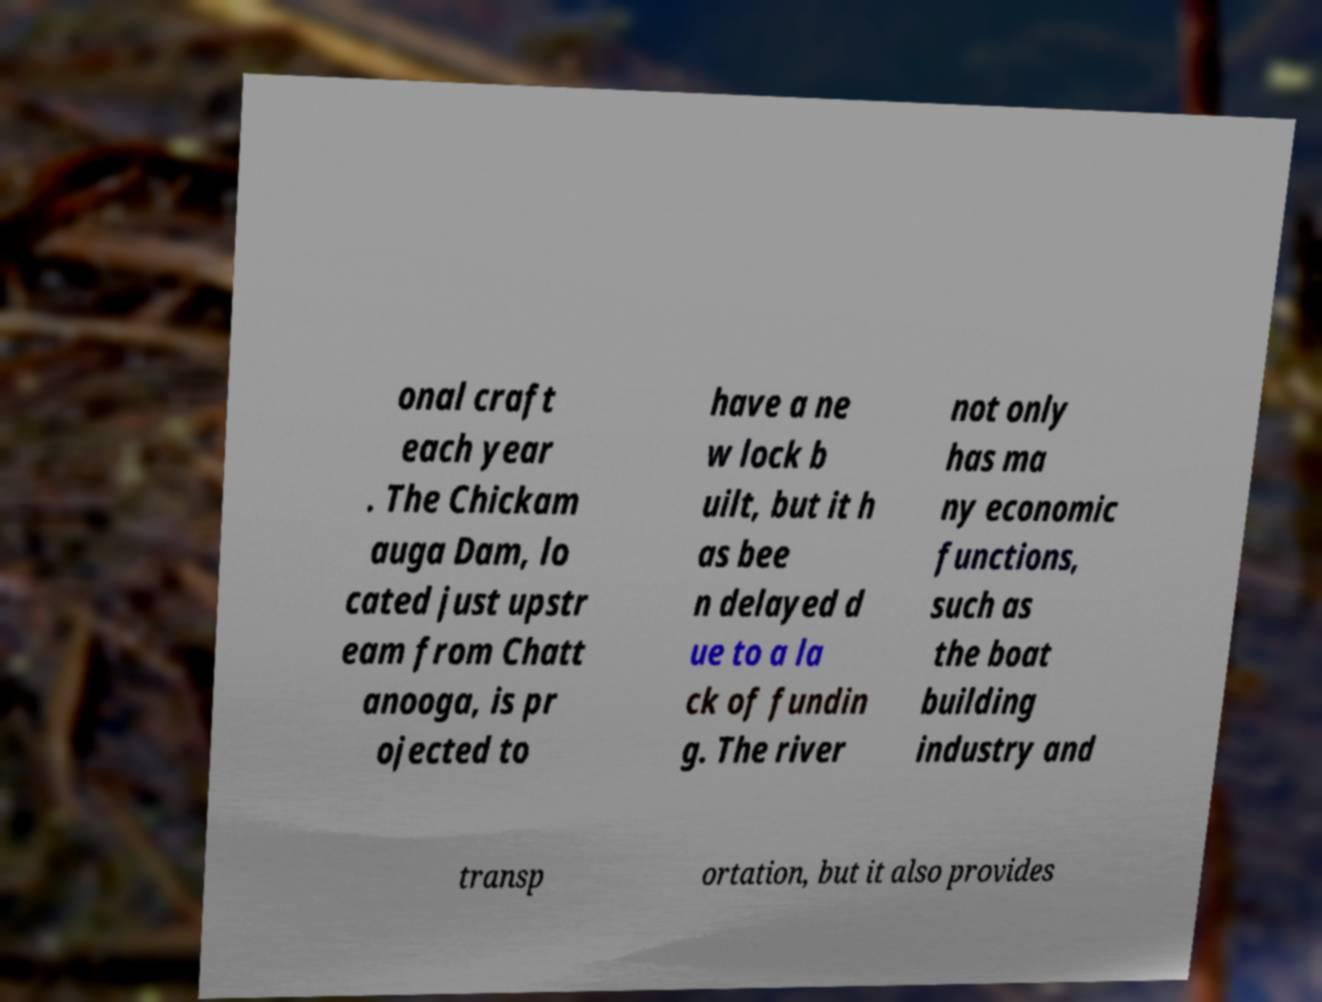Could you extract and type out the text from this image? onal craft each year . The Chickam auga Dam, lo cated just upstr eam from Chatt anooga, is pr ojected to have a ne w lock b uilt, but it h as bee n delayed d ue to a la ck of fundin g. The river not only has ma ny economic functions, such as the boat building industry and transp ortation, but it also provides 